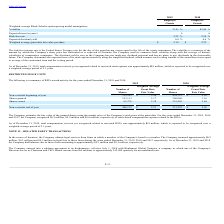From Finjan Holding's financial document, What are the respective expected terms of the 2018 and 2019 employee grants? The document shows two values: 6 and 6. From the document: "Expected term (in years) 6 6..." Also, What are the respective volatility of the 2018 and 2019 employee grants? The document shows two values: 82.00% and 73.01%. From the document: "Volatility 73.01 % 82.00 % Volatility 73.01 % 82.00 %..." Also, What are the respective risk-free rate of the 2018 and 2019 employee grants? The document shows two values: 2.24% and 2.22%. From the document: "Risk-free rate 2.22 % 2.24 % Risk-free rate 2.22 % 2.24 %..." Also, can you calculate: What is the average expected dividend yield of the 2018 and 2019 employee grants? I cannot find a specific answer to this question in the financial document. Also, can you calculate: What is the average risk-free rate in 2018 and 2019? To answer this question, I need to perform calculations using the financial data. The calculation is: (2.24 + 2.22)/2 , which equals 2.23 (percentage). This is based on the information: "Risk-free rate 2.22 % 2.24 % Risk-free rate 2.22 % 2.24 %..." The key data points involved are: 2.22, 2.24. Also, can you calculate: What is the average volatility in 2018 and 2019? To answer this question, I need to perform calculations using the financial data. The calculation is: (73.01 + 82.00)/2 , which equals 77.51 (percentage). This is based on the information: "Volatility 73.01 % 82.00 % Volatility 73.01 % 82.00 %..." The key data points involved are: 73.01, 82.00. 